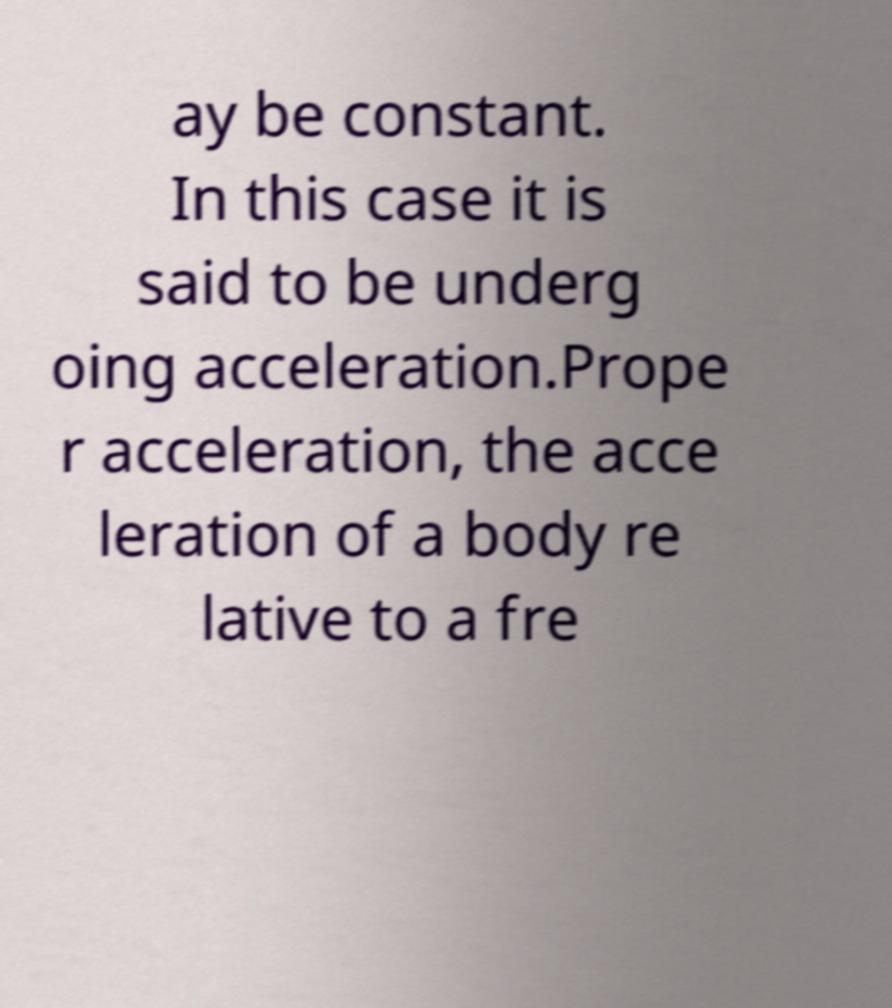Please read and relay the text visible in this image. What does it say? ay be constant. In this case it is said to be underg oing acceleration.Prope r acceleration, the acce leration of a body re lative to a fre 